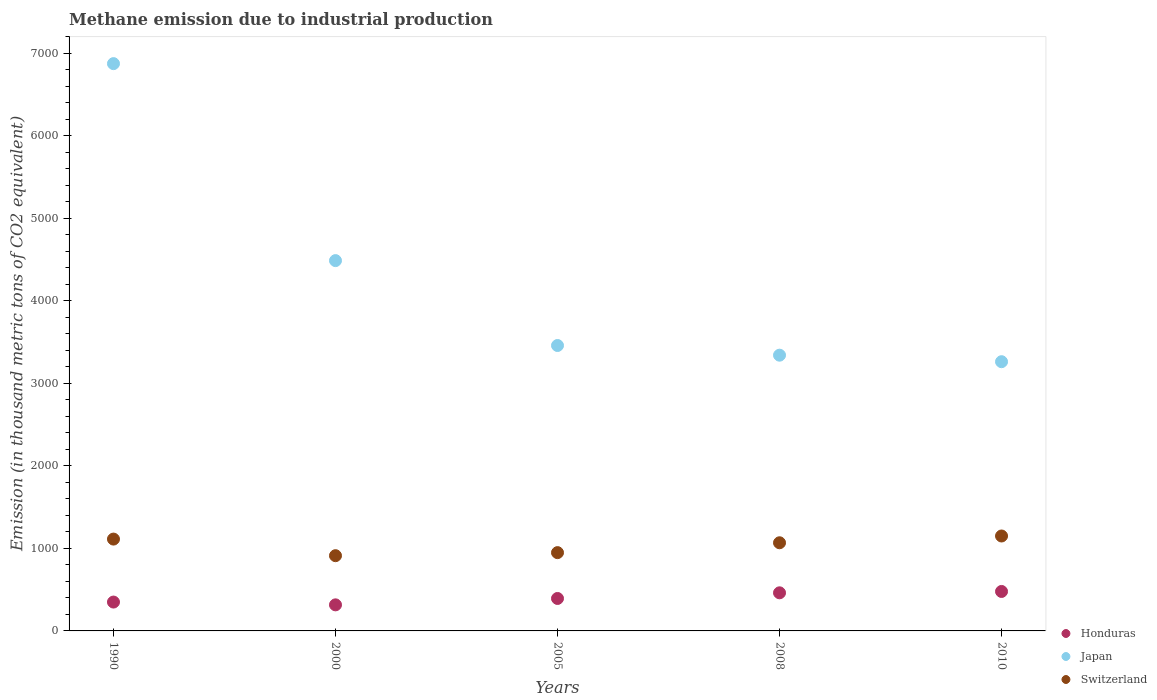Is the number of dotlines equal to the number of legend labels?
Your answer should be very brief. Yes. What is the amount of methane emitted in Japan in 2005?
Provide a succinct answer. 3458.3. Across all years, what is the maximum amount of methane emitted in Japan?
Your response must be concise. 6873.6. Across all years, what is the minimum amount of methane emitted in Honduras?
Give a very brief answer. 315.9. In which year was the amount of methane emitted in Switzerland minimum?
Make the answer very short. 2000. What is the total amount of methane emitted in Honduras in the graph?
Provide a short and direct response. 1998.6. What is the difference between the amount of methane emitted in Honduras in 2000 and that in 2008?
Provide a short and direct response. -145.8. What is the difference between the amount of methane emitted in Switzerland in 2008 and the amount of methane emitted in Honduras in 2010?
Your answer should be very brief. 590. What is the average amount of methane emitted in Honduras per year?
Provide a short and direct response. 399.72. In the year 1990, what is the difference between the amount of methane emitted in Switzerland and amount of methane emitted in Honduras?
Provide a succinct answer. 763. In how many years, is the amount of methane emitted in Switzerland greater than 5400 thousand metric tons?
Your answer should be very brief. 0. What is the ratio of the amount of methane emitted in Switzerland in 1990 to that in 2010?
Ensure brevity in your answer.  0.97. Is the amount of methane emitted in Honduras in 1990 less than that in 2005?
Offer a terse response. Yes. Is the difference between the amount of methane emitted in Switzerland in 1990 and 2010 greater than the difference between the amount of methane emitted in Honduras in 1990 and 2010?
Your response must be concise. Yes. What is the difference between the highest and the second highest amount of methane emitted in Switzerland?
Give a very brief answer. 37.5. What is the difference between the highest and the lowest amount of methane emitted in Switzerland?
Offer a terse response. 238.6. Is it the case that in every year, the sum of the amount of methane emitted in Honduras and amount of methane emitted in Switzerland  is greater than the amount of methane emitted in Japan?
Offer a very short reply. No. Is the amount of methane emitted in Switzerland strictly less than the amount of methane emitted in Japan over the years?
Make the answer very short. Yes. Does the graph contain any zero values?
Give a very brief answer. No. Where does the legend appear in the graph?
Give a very brief answer. Bottom right. How many legend labels are there?
Your response must be concise. 3. What is the title of the graph?
Your response must be concise. Methane emission due to industrial production. Does "Macao" appear as one of the legend labels in the graph?
Your answer should be compact. No. What is the label or title of the Y-axis?
Offer a terse response. Emission (in thousand metric tons of CO2 equivalent). What is the Emission (in thousand metric tons of CO2 equivalent) in Honduras in 1990?
Offer a very short reply. 349.7. What is the Emission (in thousand metric tons of CO2 equivalent) in Japan in 1990?
Keep it short and to the point. 6873.6. What is the Emission (in thousand metric tons of CO2 equivalent) in Switzerland in 1990?
Offer a very short reply. 1112.7. What is the Emission (in thousand metric tons of CO2 equivalent) in Honduras in 2000?
Ensure brevity in your answer.  315.9. What is the Emission (in thousand metric tons of CO2 equivalent) in Japan in 2000?
Provide a succinct answer. 4486.9. What is the Emission (in thousand metric tons of CO2 equivalent) of Switzerland in 2000?
Your response must be concise. 911.6. What is the Emission (in thousand metric tons of CO2 equivalent) in Honduras in 2005?
Your answer should be compact. 393.2. What is the Emission (in thousand metric tons of CO2 equivalent) of Japan in 2005?
Provide a short and direct response. 3458.3. What is the Emission (in thousand metric tons of CO2 equivalent) in Switzerland in 2005?
Keep it short and to the point. 948.6. What is the Emission (in thousand metric tons of CO2 equivalent) of Honduras in 2008?
Offer a very short reply. 461.7. What is the Emission (in thousand metric tons of CO2 equivalent) of Japan in 2008?
Keep it short and to the point. 3341. What is the Emission (in thousand metric tons of CO2 equivalent) in Switzerland in 2008?
Keep it short and to the point. 1068.1. What is the Emission (in thousand metric tons of CO2 equivalent) in Honduras in 2010?
Your answer should be compact. 478.1. What is the Emission (in thousand metric tons of CO2 equivalent) in Japan in 2010?
Offer a terse response. 3262. What is the Emission (in thousand metric tons of CO2 equivalent) in Switzerland in 2010?
Your response must be concise. 1150.2. Across all years, what is the maximum Emission (in thousand metric tons of CO2 equivalent) of Honduras?
Provide a short and direct response. 478.1. Across all years, what is the maximum Emission (in thousand metric tons of CO2 equivalent) of Japan?
Make the answer very short. 6873.6. Across all years, what is the maximum Emission (in thousand metric tons of CO2 equivalent) of Switzerland?
Keep it short and to the point. 1150.2. Across all years, what is the minimum Emission (in thousand metric tons of CO2 equivalent) in Honduras?
Offer a terse response. 315.9. Across all years, what is the minimum Emission (in thousand metric tons of CO2 equivalent) of Japan?
Your answer should be very brief. 3262. Across all years, what is the minimum Emission (in thousand metric tons of CO2 equivalent) of Switzerland?
Make the answer very short. 911.6. What is the total Emission (in thousand metric tons of CO2 equivalent) in Honduras in the graph?
Give a very brief answer. 1998.6. What is the total Emission (in thousand metric tons of CO2 equivalent) of Japan in the graph?
Offer a very short reply. 2.14e+04. What is the total Emission (in thousand metric tons of CO2 equivalent) of Switzerland in the graph?
Your response must be concise. 5191.2. What is the difference between the Emission (in thousand metric tons of CO2 equivalent) in Honduras in 1990 and that in 2000?
Offer a terse response. 33.8. What is the difference between the Emission (in thousand metric tons of CO2 equivalent) of Japan in 1990 and that in 2000?
Provide a succinct answer. 2386.7. What is the difference between the Emission (in thousand metric tons of CO2 equivalent) of Switzerland in 1990 and that in 2000?
Offer a terse response. 201.1. What is the difference between the Emission (in thousand metric tons of CO2 equivalent) of Honduras in 1990 and that in 2005?
Make the answer very short. -43.5. What is the difference between the Emission (in thousand metric tons of CO2 equivalent) in Japan in 1990 and that in 2005?
Your answer should be compact. 3415.3. What is the difference between the Emission (in thousand metric tons of CO2 equivalent) of Switzerland in 1990 and that in 2005?
Your answer should be very brief. 164.1. What is the difference between the Emission (in thousand metric tons of CO2 equivalent) in Honduras in 1990 and that in 2008?
Your response must be concise. -112. What is the difference between the Emission (in thousand metric tons of CO2 equivalent) of Japan in 1990 and that in 2008?
Give a very brief answer. 3532.6. What is the difference between the Emission (in thousand metric tons of CO2 equivalent) in Switzerland in 1990 and that in 2008?
Keep it short and to the point. 44.6. What is the difference between the Emission (in thousand metric tons of CO2 equivalent) of Honduras in 1990 and that in 2010?
Provide a succinct answer. -128.4. What is the difference between the Emission (in thousand metric tons of CO2 equivalent) in Japan in 1990 and that in 2010?
Provide a short and direct response. 3611.6. What is the difference between the Emission (in thousand metric tons of CO2 equivalent) in Switzerland in 1990 and that in 2010?
Make the answer very short. -37.5. What is the difference between the Emission (in thousand metric tons of CO2 equivalent) in Honduras in 2000 and that in 2005?
Your answer should be compact. -77.3. What is the difference between the Emission (in thousand metric tons of CO2 equivalent) of Japan in 2000 and that in 2005?
Make the answer very short. 1028.6. What is the difference between the Emission (in thousand metric tons of CO2 equivalent) of Switzerland in 2000 and that in 2005?
Your answer should be very brief. -37. What is the difference between the Emission (in thousand metric tons of CO2 equivalent) of Honduras in 2000 and that in 2008?
Ensure brevity in your answer.  -145.8. What is the difference between the Emission (in thousand metric tons of CO2 equivalent) in Japan in 2000 and that in 2008?
Give a very brief answer. 1145.9. What is the difference between the Emission (in thousand metric tons of CO2 equivalent) in Switzerland in 2000 and that in 2008?
Offer a very short reply. -156.5. What is the difference between the Emission (in thousand metric tons of CO2 equivalent) in Honduras in 2000 and that in 2010?
Make the answer very short. -162.2. What is the difference between the Emission (in thousand metric tons of CO2 equivalent) of Japan in 2000 and that in 2010?
Provide a succinct answer. 1224.9. What is the difference between the Emission (in thousand metric tons of CO2 equivalent) of Switzerland in 2000 and that in 2010?
Offer a terse response. -238.6. What is the difference between the Emission (in thousand metric tons of CO2 equivalent) of Honduras in 2005 and that in 2008?
Provide a succinct answer. -68.5. What is the difference between the Emission (in thousand metric tons of CO2 equivalent) in Japan in 2005 and that in 2008?
Your response must be concise. 117.3. What is the difference between the Emission (in thousand metric tons of CO2 equivalent) of Switzerland in 2005 and that in 2008?
Keep it short and to the point. -119.5. What is the difference between the Emission (in thousand metric tons of CO2 equivalent) in Honduras in 2005 and that in 2010?
Provide a succinct answer. -84.9. What is the difference between the Emission (in thousand metric tons of CO2 equivalent) of Japan in 2005 and that in 2010?
Keep it short and to the point. 196.3. What is the difference between the Emission (in thousand metric tons of CO2 equivalent) of Switzerland in 2005 and that in 2010?
Provide a succinct answer. -201.6. What is the difference between the Emission (in thousand metric tons of CO2 equivalent) of Honduras in 2008 and that in 2010?
Offer a terse response. -16.4. What is the difference between the Emission (in thousand metric tons of CO2 equivalent) of Japan in 2008 and that in 2010?
Give a very brief answer. 79. What is the difference between the Emission (in thousand metric tons of CO2 equivalent) in Switzerland in 2008 and that in 2010?
Keep it short and to the point. -82.1. What is the difference between the Emission (in thousand metric tons of CO2 equivalent) in Honduras in 1990 and the Emission (in thousand metric tons of CO2 equivalent) in Japan in 2000?
Your response must be concise. -4137.2. What is the difference between the Emission (in thousand metric tons of CO2 equivalent) of Honduras in 1990 and the Emission (in thousand metric tons of CO2 equivalent) of Switzerland in 2000?
Offer a very short reply. -561.9. What is the difference between the Emission (in thousand metric tons of CO2 equivalent) in Japan in 1990 and the Emission (in thousand metric tons of CO2 equivalent) in Switzerland in 2000?
Offer a very short reply. 5962. What is the difference between the Emission (in thousand metric tons of CO2 equivalent) of Honduras in 1990 and the Emission (in thousand metric tons of CO2 equivalent) of Japan in 2005?
Your answer should be very brief. -3108.6. What is the difference between the Emission (in thousand metric tons of CO2 equivalent) of Honduras in 1990 and the Emission (in thousand metric tons of CO2 equivalent) of Switzerland in 2005?
Offer a very short reply. -598.9. What is the difference between the Emission (in thousand metric tons of CO2 equivalent) of Japan in 1990 and the Emission (in thousand metric tons of CO2 equivalent) of Switzerland in 2005?
Ensure brevity in your answer.  5925. What is the difference between the Emission (in thousand metric tons of CO2 equivalent) in Honduras in 1990 and the Emission (in thousand metric tons of CO2 equivalent) in Japan in 2008?
Offer a very short reply. -2991.3. What is the difference between the Emission (in thousand metric tons of CO2 equivalent) in Honduras in 1990 and the Emission (in thousand metric tons of CO2 equivalent) in Switzerland in 2008?
Your answer should be compact. -718.4. What is the difference between the Emission (in thousand metric tons of CO2 equivalent) of Japan in 1990 and the Emission (in thousand metric tons of CO2 equivalent) of Switzerland in 2008?
Offer a terse response. 5805.5. What is the difference between the Emission (in thousand metric tons of CO2 equivalent) in Honduras in 1990 and the Emission (in thousand metric tons of CO2 equivalent) in Japan in 2010?
Offer a terse response. -2912.3. What is the difference between the Emission (in thousand metric tons of CO2 equivalent) in Honduras in 1990 and the Emission (in thousand metric tons of CO2 equivalent) in Switzerland in 2010?
Give a very brief answer. -800.5. What is the difference between the Emission (in thousand metric tons of CO2 equivalent) of Japan in 1990 and the Emission (in thousand metric tons of CO2 equivalent) of Switzerland in 2010?
Offer a very short reply. 5723.4. What is the difference between the Emission (in thousand metric tons of CO2 equivalent) of Honduras in 2000 and the Emission (in thousand metric tons of CO2 equivalent) of Japan in 2005?
Your answer should be very brief. -3142.4. What is the difference between the Emission (in thousand metric tons of CO2 equivalent) in Honduras in 2000 and the Emission (in thousand metric tons of CO2 equivalent) in Switzerland in 2005?
Provide a short and direct response. -632.7. What is the difference between the Emission (in thousand metric tons of CO2 equivalent) of Japan in 2000 and the Emission (in thousand metric tons of CO2 equivalent) of Switzerland in 2005?
Provide a short and direct response. 3538.3. What is the difference between the Emission (in thousand metric tons of CO2 equivalent) of Honduras in 2000 and the Emission (in thousand metric tons of CO2 equivalent) of Japan in 2008?
Your response must be concise. -3025.1. What is the difference between the Emission (in thousand metric tons of CO2 equivalent) of Honduras in 2000 and the Emission (in thousand metric tons of CO2 equivalent) of Switzerland in 2008?
Offer a very short reply. -752.2. What is the difference between the Emission (in thousand metric tons of CO2 equivalent) of Japan in 2000 and the Emission (in thousand metric tons of CO2 equivalent) of Switzerland in 2008?
Ensure brevity in your answer.  3418.8. What is the difference between the Emission (in thousand metric tons of CO2 equivalent) in Honduras in 2000 and the Emission (in thousand metric tons of CO2 equivalent) in Japan in 2010?
Offer a terse response. -2946.1. What is the difference between the Emission (in thousand metric tons of CO2 equivalent) in Honduras in 2000 and the Emission (in thousand metric tons of CO2 equivalent) in Switzerland in 2010?
Provide a succinct answer. -834.3. What is the difference between the Emission (in thousand metric tons of CO2 equivalent) of Japan in 2000 and the Emission (in thousand metric tons of CO2 equivalent) of Switzerland in 2010?
Your response must be concise. 3336.7. What is the difference between the Emission (in thousand metric tons of CO2 equivalent) in Honduras in 2005 and the Emission (in thousand metric tons of CO2 equivalent) in Japan in 2008?
Keep it short and to the point. -2947.8. What is the difference between the Emission (in thousand metric tons of CO2 equivalent) in Honduras in 2005 and the Emission (in thousand metric tons of CO2 equivalent) in Switzerland in 2008?
Give a very brief answer. -674.9. What is the difference between the Emission (in thousand metric tons of CO2 equivalent) of Japan in 2005 and the Emission (in thousand metric tons of CO2 equivalent) of Switzerland in 2008?
Your answer should be compact. 2390.2. What is the difference between the Emission (in thousand metric tons of CO2 equivalent) in Honduras in 2005 and the Emission (in thousand metric tons of CO2 equivalent) in Japan in 2010?
Offer a very short reply. -2868.8. What is the difference between the Emission (in thousand metric tons of CO2 equivalent) in Honduras in 2005 and the Emission (in thousand metric tons of CO2 equivalent) in Switzerland in 2010?
Provide a short and direct response. -757. What is the difference between the Emission (in thousand metric tons of CO2 equivalent) of Japan in 2005 and the Emission (in thousand metric tons of CO2 equivalent) of Switzerland in 2010?
Ensure brevity in your answer.  2308.1. What is the difference between the Emission (in thousand metric tons of CO2 equivalent) in Honduras in 2008 and the Emission (in thousand metric tons of CO2 equivalent) in Japan in 2010?
Give a very brief answer. -2800.3. What is the difference between the Emission (in thousand metric tons of CO2 equivalent) in Honduras in 2008 and the Emission (in thousand metric tons of CO2 equivalent) in Switzerland in 2010?
Your answer should be very brief. -688.5. What is the difference between the Emission (in thousand metric tons of CO2 equivalent) in Japan in 2008 and the Emission (in thousand metric tons of CO2 equivalent) in Switzerland in 2010?
Offer a terse response. 2190.8. What is the average Emission (in thousand metric tons of CO2 equivalent) in Honduras per year?
Your answer should be compact. 399.72. What is the average Emission (in thousand metric tons of CO2 equivalent) in Japan per year?
Offer a terse response. 4284.36. What is the average Emission (in thousand metric tons of CO2 equivalent) of Switzerland per year?
Your answer should be very brief. 1038.24. In the year 1990, what is the difference between the Emission (in thousand metric tons of CO2 equivalent) in Honduras and Emission (in thousand metric tons of CO2 equivalent) in Japan?
Provide a succinct answer. -6523.9. In the year 1990, what is the difference between the Emission (in thousand metric tons of CO2 equivalent) of Honduras and Emission (in thousand metric tons of CO2 equivalent) of Switzerland?
Ensure brevity in your answer.  -763. In the year 1990, what is the difference between the Emission (in thousand metric tons of CO2 equivalent) of Japan and Emission (in thousand metric tons of CO2 equivalent) of Switzerland?
Keep it short and to the point. 5760.9. In the year 2000, what is the difference between the Emission (in thousand metric tons of CO2 equivalent) in Honduras and Emission (in thousand metric tons of CO2 equivalent) in Japan?
Provide a short and direct response. -4171. In the year 2000, what is the difference between the Emission (in thousand metric tons of CO2 equivalent) in Honduras and Emission (in thousand metric tons of CO2 equivalent) in Switzerland?
Your response must be concise. -595.7. In the year 2000, what is the difference between the Emission (in thousand metric tons of CO2 equivalent) of Japan and Emission (in thousand metric tons of CO2 equivalent) of Switzerland?
Give a very brief answer. 3575.3. In the year 2005, what is the difference between the Emission (in thousand metric tons of CO2 equivalent) in Honduras and Emission (in thousand metric tons of CO2 equivalent) in Japan?
Provide a short and direct response. -3065.1. In the year 2005, what is the difference between the Emission (in thousand metric tons of CO2 equivalent) of Honduras and Emission (in thousand metric tons of CO2 equivalent) of Switzerland?
Your answer should be compact. -555.4. In the year 2005, what is the difference between the Emission (in thousand metric tons of CO2 equivalent) of Japan and Emission (in thousand metric tons of CO2 equivalent) of Switzerland?
Offer a terse response. 2509.7. In the year 2008, what is the difference between the Emission (in thousand metric tons of CO2 equivalent) of Honduras and Emission (in thousand metric tons of CO2 equivalent) of Japan?
Provide a short and direct response. -2879.3. In the year 2008, what is the difference between the Emission (in thousand metric tons of CO2 equivalent) in Honduras and Emission (in thousand metric tons of CO2 equivalent) in Switzerland?
Offer a very short reply. -606.4. In the year 2008, what is the difference between the Emission (in thousand metric tons of CO2 equivalent) of Japan and Emission (in thousand metric tons of CO2 equivalent) of Switzerland?
Ensure brevity in your answer.  2272.9. In the year 2010, what is the difference between the Emission (in thousand metric tons of CO2 equivalent) of Honduras and Emission (in thousand metric tons of CO2 equivalent) of Japan?
Your answer should be very brief. -2783.9. In the year 2010, what is the difference between the Emission (in thousand metric tons of CO2 equivalent) in Honduras and Emission (in thousand metric tons of CO2 equivalent) in Switzerland?
Offer a very short reply. -672.1. In the year 2010, what is the difference between the Emission (in thousand metric tons of CO2 equivalent) in Japan and Emission (in thousand metric tons of CO2 equivalent) in Switzerland?
Your answer should be compact. 2111.8. What is the ratio of the Emission (in thousand metric tons of CO2 equivalent) in Honduras in 1990 to that in 2000?
Provide a short and direct response. 1.11. What is the ratio of the Emission (in thousand metric tons of CO2 equivalent) in Japan in 1990 to that in 2000?
Your answer should be compact. 1.53. What is the ratio of the Emission (in thousand metric tons of CO2 equivalent) of Switzerland in 1990 to that in 2000?
Give a very brief answer. 1.22. What is the ratio of the Emission (in thousand metric tons of CO2 equivalent) in Honduras in 1990 to that in 2005?
Offer a very short reply. 0.89. What is the ratio of the Emission (in thousand metric tons of CO2 equivalent) in Japan in 1990 to that in 2005?
Your answer should be compact. 1.99. What is the ratio of the Emission (in thousand metric tons of CO2 equivalent) of Switzerland in 1990 to that in 2005?
Give a very brief answer. 1.17. What is the ratio of the Emission (in thousand metric tons of CO2 equivalent) of Honduras in 1990 to that in 2008?
Give a very brief answer. 0.76. What is the ratio of the Emission (in thousand metric tons of CO2 equivalent) in Japan in 1990 to that in 2008?
Keep it short and to the point. 2.06. What is the ratio of the Emission (in thousand metric tons of CO2 equivalent) of Switzerland in 1990 to that in 2008?
Offer a very short reply. 1.04. What is the ratio of the Emission (in thousand metric tons of CO2 equivalent) of Honduras in 1990 to that in 2010?
Keep it short and to the point. 0.73. What is the ratio of the Emission (in thousand metric tons of CO2 equivalent) of Japan in 1990 to that in 2010?
Make the answer very short. 2.11. What is the ratio of the Emission (in thousand metric tons of CO2 equivalent) in Switzerland in 1990 to that in 2010?
Keep it short and to the point. 0.97. What is the ratio of the Emission (in thousand metric tons of CO2 equivalent) in Honduras in 2000 to that in 2005?
Provide a succinct answer. 0.8. What is the ratio of the Emission (in thousand metric tons of CO2 equivalent) in Japan in 2000 to that in 2005?
Give a very brief answer. 1.3. What is the ratio of the Emission (in thousand metric tons of CO2 equivalent) of Switzerland in 2000 to that in 2005?
Provide a succinct answer. 0.96. What is the ratio of the Emission (in thousand metric tons of CO2 equivalent) in Honduras in 2000 to that in 2008?
Provide a short and direct response. 0.68. What is the ratio of the Emission (in thousand metric tons of CO2 equivalent) in Japan in 2000 to that in 2008?
Ensure brevity in your answer.  1.34. What is the ratio of the Emission (in thousand metric tons of CO2 equivalent) of Switzerland in 2000 to that in 2008?
Keep it short and to the point. 0.85. What is the ratio of the Emission (in thousand metric tons of CO2 equivalent) in Honduras in 2000 to that in 2010?
Your answer should be very brief. 0.66. What is the ratio of the Emission (in thousand metric tons of CO2 equivalent) in Japan in 2000 to that in 2010?
Provide a short and direct response. 1.38. What is the ratio of the Emission (in thousand metric tons of CO2 equivalent) of Switzerland in 2000 to that in 2010?
Offer a very short reply. 0.79. What is the ratio of the Emission (in thousand metric tons of CO2 equivalent) in Honduras in 2005 to that in 2008?
Your response must be concise. 0.85. What is the ratio of the Emission (in thousand metric tons of CO2 equivalent) in Japan in 2005 to that in 2008?
Your answer should be compact. 1.04. What is the ratio of the Emission (in thousand metric tons of CO2 equivalent) in Switzerland in 2005 to that in 2008?
Offer a very short reply. 0.89. What is the ratio of the Emission (in thousand metric tons of CO2 equivalent) in Honduras in 2005 to that in 2010?
Provide a succinct answer. 0.82. What is the ratio of the Emission (in thousand metric tons of CO2 equivalent) of Japan in 2005 to that in 2010?
Offer a terse response. 1.06. What is the ratio of the Emission (in thousand metric tons of CO2 equivalent) in Switzerland in 2005 to that in 2010?
Your answer should be very brief. 0.82. What is the ratio of the Emission (in thousand metric tons of CO2 equivalent) in Honduras in 2008 to that in 2010?
Offer a terse response. 0.97. What is the ratio of the Emission (in thousand metric tons of CO2 equivalent) of Japan in 2008 to that in 2010?
Provide a short and direct response. 1.02. What is the difference between the highest and the second highest Emission (in thousand metric tons of CO2 equivalent) of Japan?
Offer a very short reply. 2386.7. What is the difference between the highest and the second highest Emission (in thousand metric tons of CO2 equivalent) of Switzerland?
Provide a succinct answer. 37.5. What is the difference between the highest and the lowest Emission (in thousand metric tons of CO2 equivalent) in Honduras?
Your answer should be compact. 162.2. What is the difference between the highest and the lowest Emission (in thousand metric tons of CO2 equivalent) in Japan?
Ensure brevity in your answer.  3611.6. What is the difference between the highest and the lowest Emission (in thousand metric tons of CO2 equivalent) of Switzerland?
Ensure brevity in your answer.  238.6. 